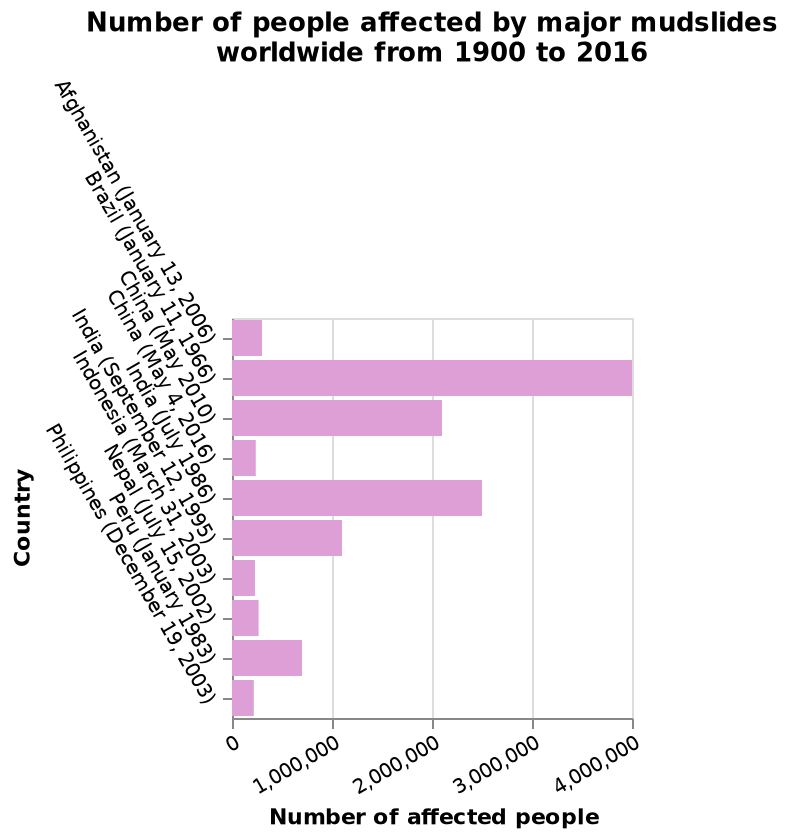<image>
What is the time period covered by the bar chart? The time period covered by the bar chart is from 1900 to 2016. please summary the statistics and relations of the chart The country with the largest number of people affected by mudslide incidents is Brazil, at 4million. China and India are the only countries shown on the graph to have had 2 mudslide incidents. Half of the mudslides shown affected less than 300,000 people. In which areas does the graph show an increase in affected people? The graph shows an increase in affected people specifically in areas of major population. Where has there been an increase in affected people?  There has been an increase in affected people in areas of major population, according to the graph. 